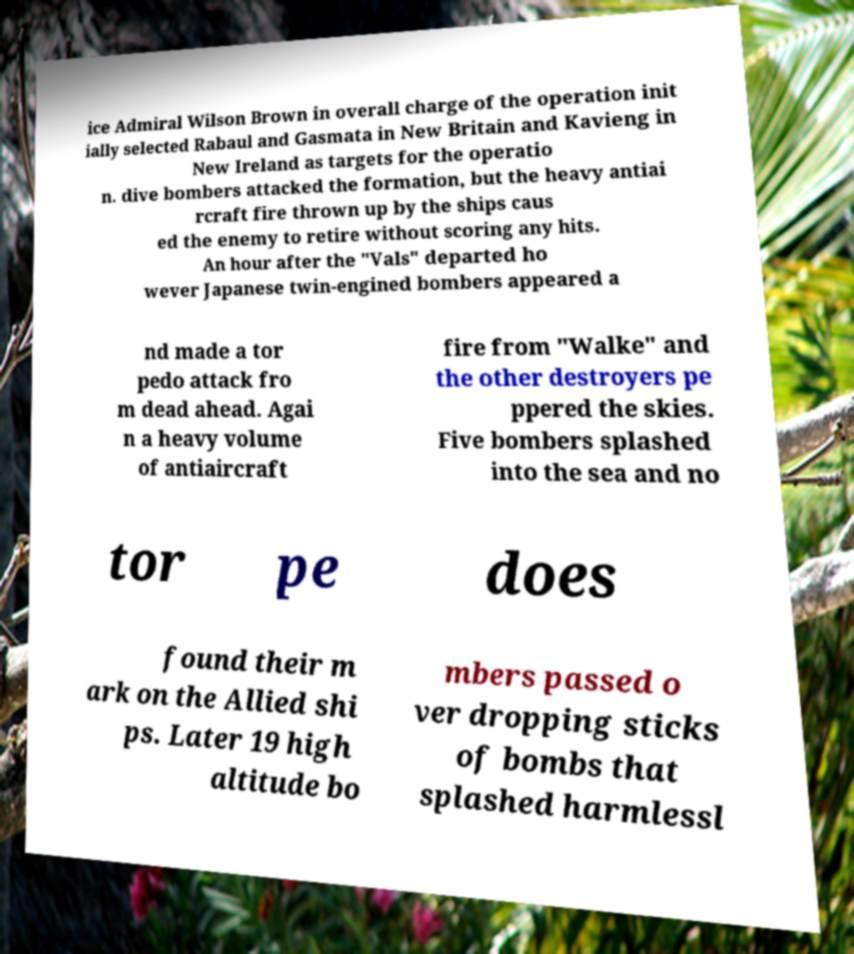Please read and relay the text visible in this image. What does it say? ice Admiral Wilson Brown in overall charge of the operation init ially selected Rabaul and Gasmata in New Britain and Kavieng in New Ireland as targets for the operatio n. dive bombers attacked the formation, but the heavy antiai rcraft fire thrown up by the ships caus ed the enemy to retire without scoring any hits. An hour after the "Vals" departed ho wever Japanese twin-engined bombers appeared a nd made a tor pedo attack fro m dead ahead. Agai n a heavy volume of antiaircraft fire from "Walke" and the other destroyers pe ppered the skies. Five bombers splashed into the sea and no tor pe does found their m ark on the Allied shi ps. Later 19 high altitude bo mbers passed o ver dropping sticks of bombs that splashed harmlessl 